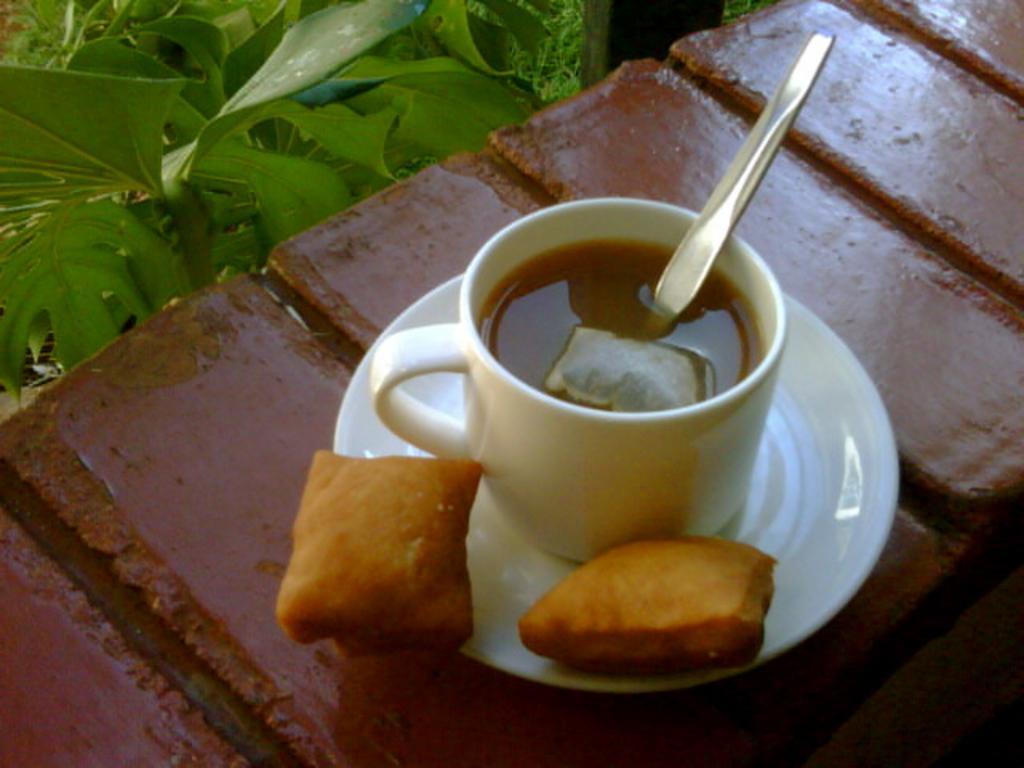Describe this image in one or two sentences. In this image, we can see a white color saucer, there is a white color tea cup kept in the saucer, there is a spoon kept in the cup, there is a green color plant. 